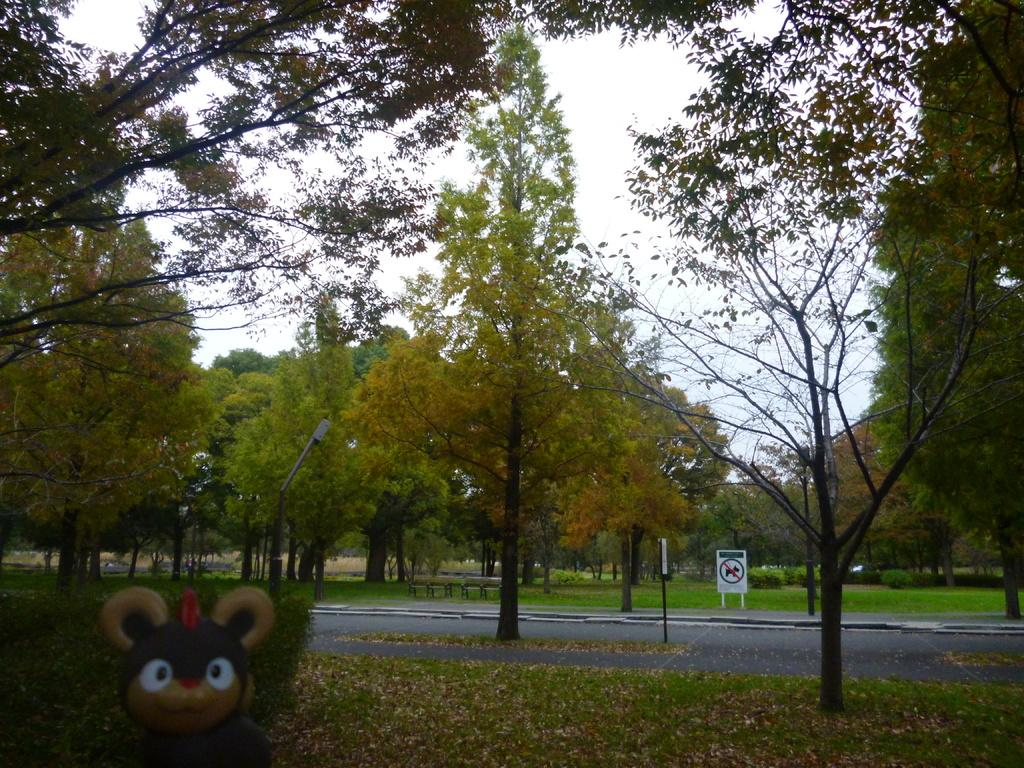What type of vegetation can be seen in the image? There are trees and grass in the image. What is the surface on which the dry leaves are visible? The dry leaves are visible on the surface in the image. What type of signage is present on the road in the image? Sign boards are present on the road in the image. What additional object can be seen in the image? There is a toy in the image. What type of shade is provided by the trees in the image? There is no mention of shade provided by the trees in the image; we only know that there are trees present. What type of stew is being cooked in the image? There is no indication of any cooking or stew in the image; it primarily features trees, grass, sign boards, dry leaves, and a toy. 